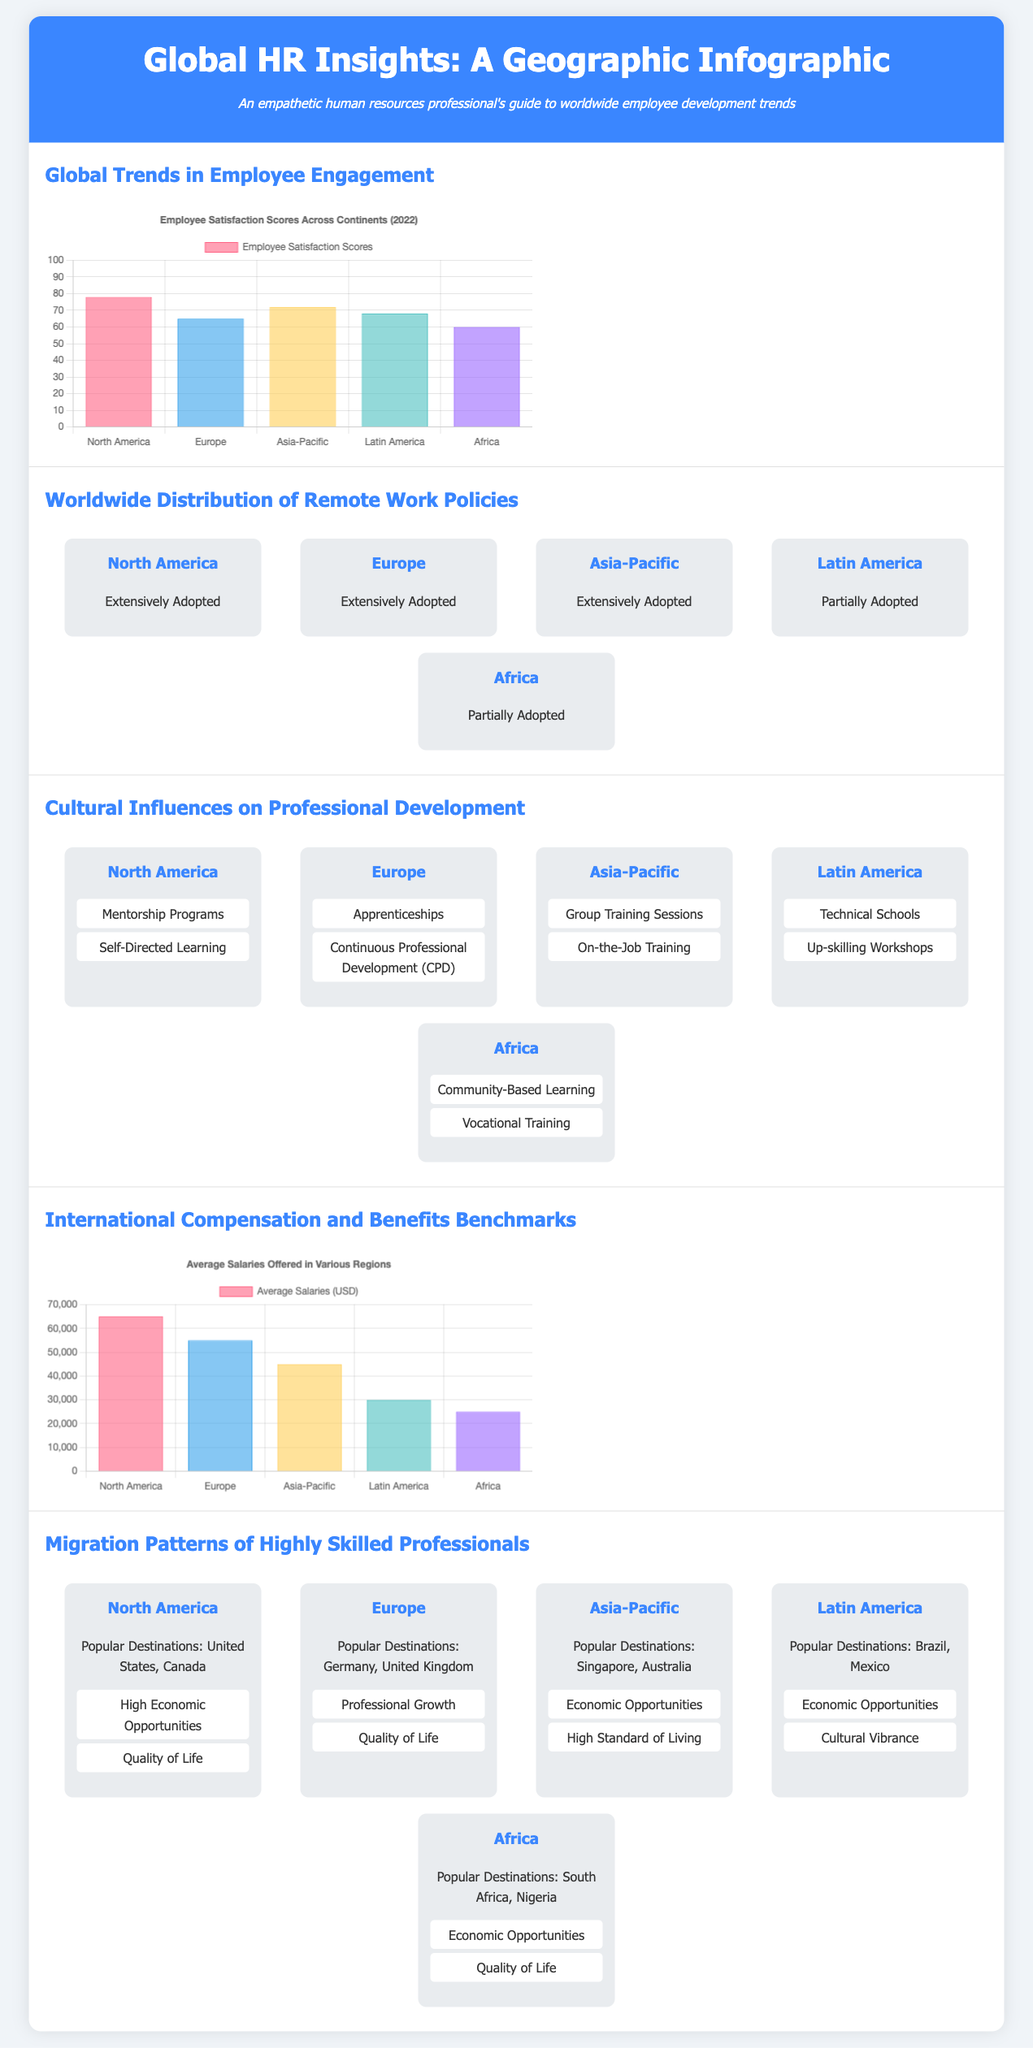What is the employee satisfaction score in North America? The employee satisfaction score in North America is presented in the infographic, specifically showing a score of 78.
Answer: 78 Which region has the highest average salary? The infographic shows a comparison of average salaries across regions, indicating that North America has the highest average salary of 65000 USD.
Answer: North America What cultural practice is highlighted for Asia-Pacific in professional development? The map-based infographic outlines that Asia-Pacific emphasizes Group Training Sessions as a key cultural practice in professional development.
Answer: Group Training Sessions Which two regions have extensively adopted remote work policies? The infographic details the adoption of remote work policies and specifies that North America and Europe have both extensively adopted these policies.
Answer: North America, Europe What is the average salary in Latin America? The average salary for Latin America is displayed in the salary chart, showing a figure of 30000 USD.
Answer: 30000 Which factor is a reason for migration patterns in Asia-Pacific? The infographic provides factors for migration patterns, listing Economic Opportunities as a key reason for migration in Asia-Pacific.
Answer: Economic Opportunities What is the primary professional development practice in Europe? The infographic indicates that Apprenticeships are a primary professional development practice in Europe.
Answer: Apprenticeships What is the employee satisfaction score in Africa? The document indicates that the employee satisfaction score in Africa is 60 according to the engagement chart.
Answer: 60 How many regions have partially adopted remote work policies? The infographic indicates that two regions, Latin America and Africa, have partially adopted remote work policies.
Answer: Two 